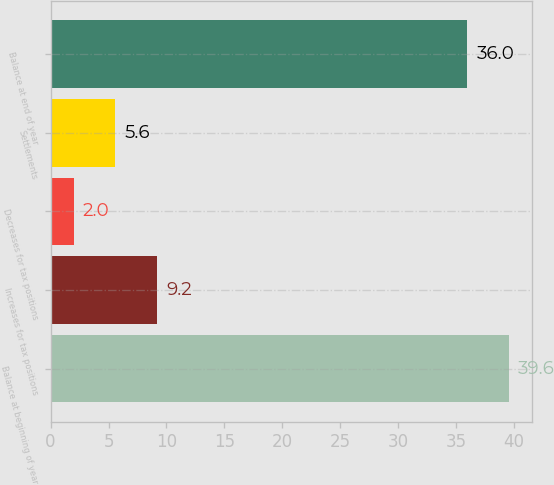Convert chart. <chart><loc_0><loc_0><loc_500><loc_500><bar_chart><fcel>Balance at beginning of year<fcel>Increases for tax positions<fcel>Decreases for tax positions<fcel>Settlements<fcel>Balance at end of year<nl><fcel>39.6<fcel>9.2<fcel>2<fcel>5.6<fcel>36<nl></chart> 